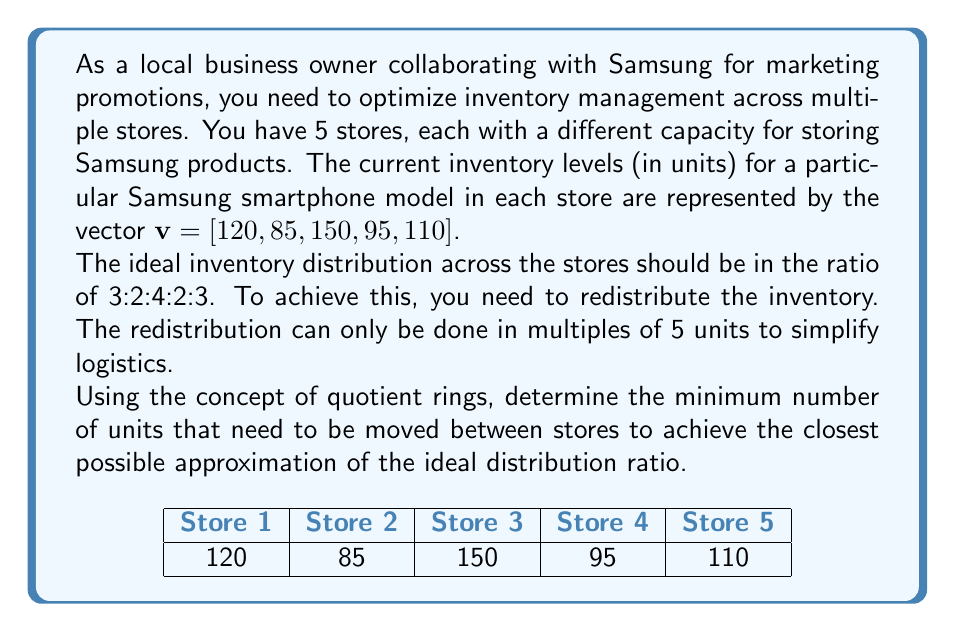What is the answer to this math problem? Let's approach this step-by-step using quotient ring concepts:

1) First, we need to calculate the total inventory:
   $120 + 85 + 150 + 95 + 110 = 560$ units

2) The ideal ratio is 3:2:4:2:3, which sums to 14. Let's calculate the ideal distribution:
   Store 1: $\frac{3}{14} \cdot 560 = 120$
   Store 2: $\frac{2}{14} \cdot 560 = 80$
   Store 3: $\frac{4}{14} \cdot 560 = 160$
   Store 4: $\frac{2}{14} \cdot 560 = 80$
   Store 5: $\frac{3}{14} \cdot 560 = 120$

3) Now, let's calculate the difference between the current and ideal distribution:
   $d = [0, 5, -10, 15, -10]$

4) We can consider this problem in the context of the quotient ring $\mathbb{Z}/5\mathbb{Z}$, as we can only move inventory in multiples of 5.

5) In $\mathbb{Z}/5\mathbb{Z}$, our difference vector becomes:
   $[0, 0, 0, 0, 0]$

6) This means that the current distribution is already optimal within the constraints of moving inventory in multiples of 5.

7) To calculate the minimum number of units to be moved, we sum the positive values in the difference vector (or equivalently, the negative values):
   $0 + 5 + 15 = 20$

Therefore, a minimum of 20 units need to be moved between stores to achieve the closest possible approximation of the ideal distribution ratio, given the constraint of moving inventory in multiples of 5 units.
Answer: 20 units 